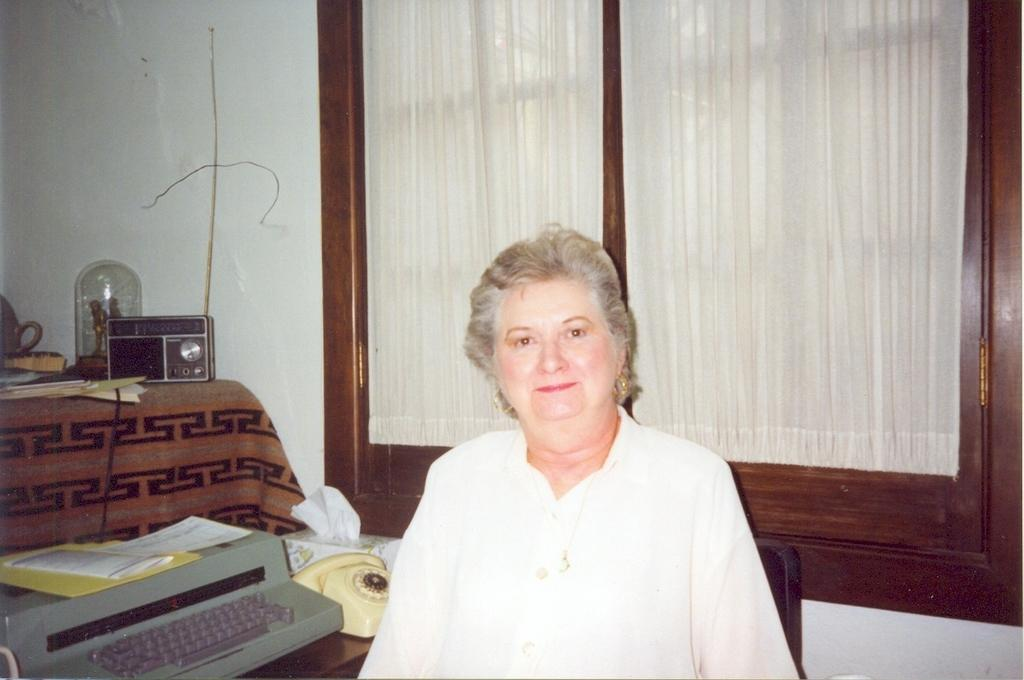What is the main subject of the image? There is a woman standing in the image. What can be seen in the background of the image? There is a window in the image. What object is present that is typically used for communication? There is a telephone in the image. Can you describe the unspecified "other object" in the image? Unfortunately, the facts provided do not give any details about the other object in the image. What type of coal is being used to play with the balls in the image? There is no coal or balls present in the image, so this question cannot be answered. 